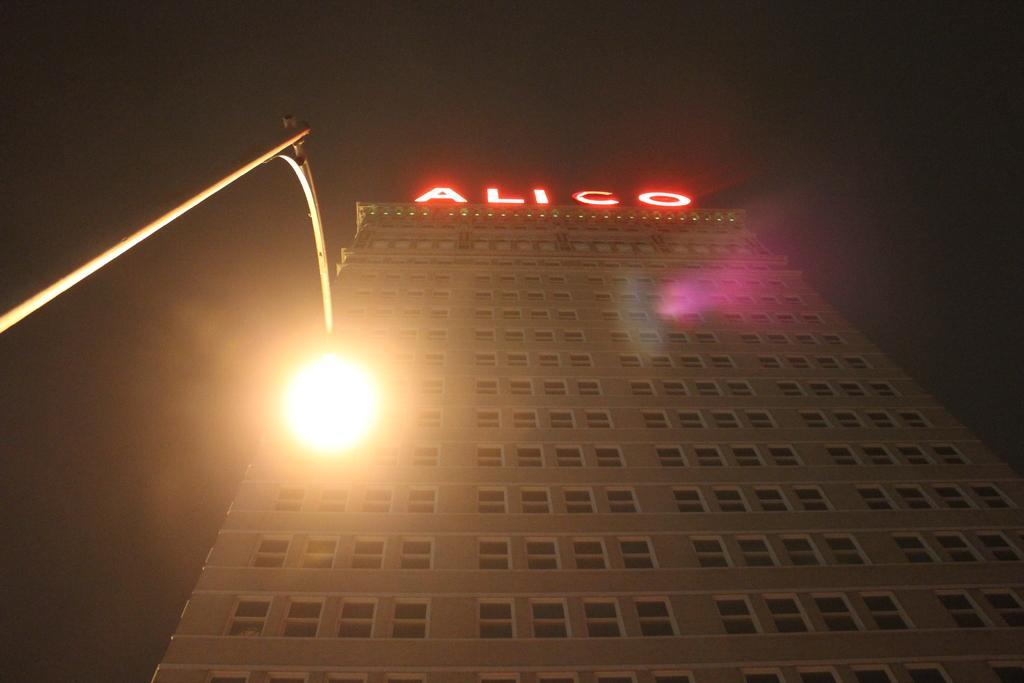Can you describe this image briefly? In this image, we can see a building with walls and windows. Left side of the image, there is a street light with pole. Background there is a sky. 